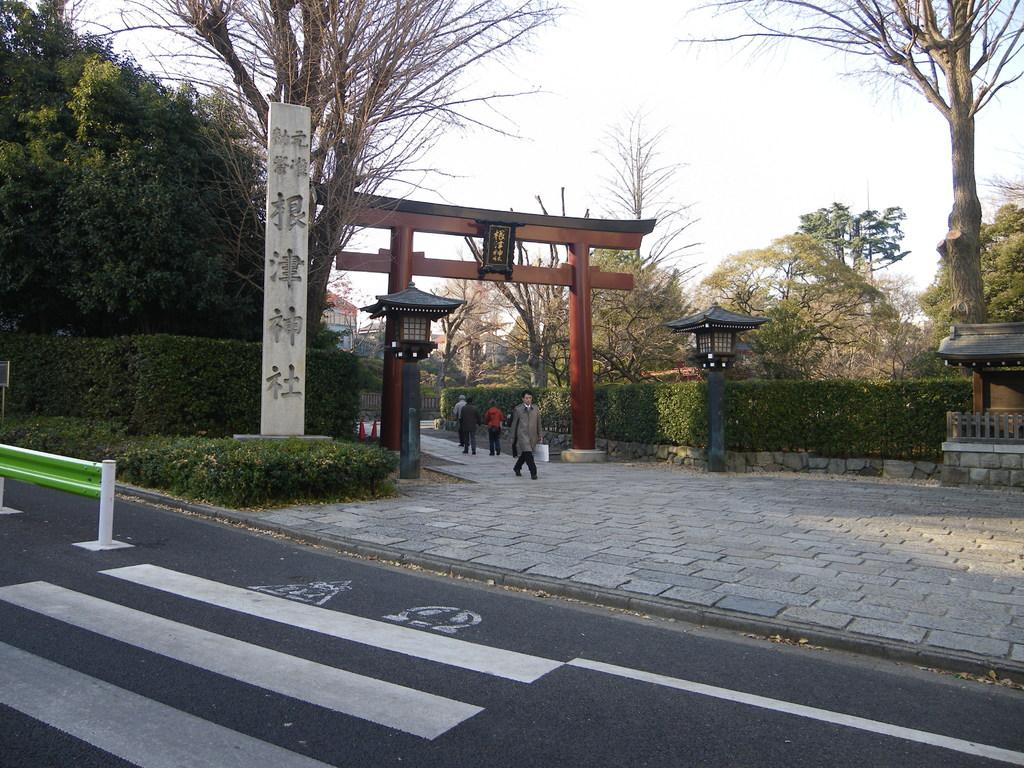How many people are present in the image? There are four persons in the image. What else can be seen in the image besides the people? There are plants, a road, pillars, trees, buildings, and the sky visible in the image. Can you describe the natural elements in the image? There are plants, trees, and the sky visible in the image. What type of man-made structures are present in the image? There are pillars, buildings, and a road visible in the image. What type of order is being given on the stage in the image? There is no stage present in the image, so no order can be given on a stage. 